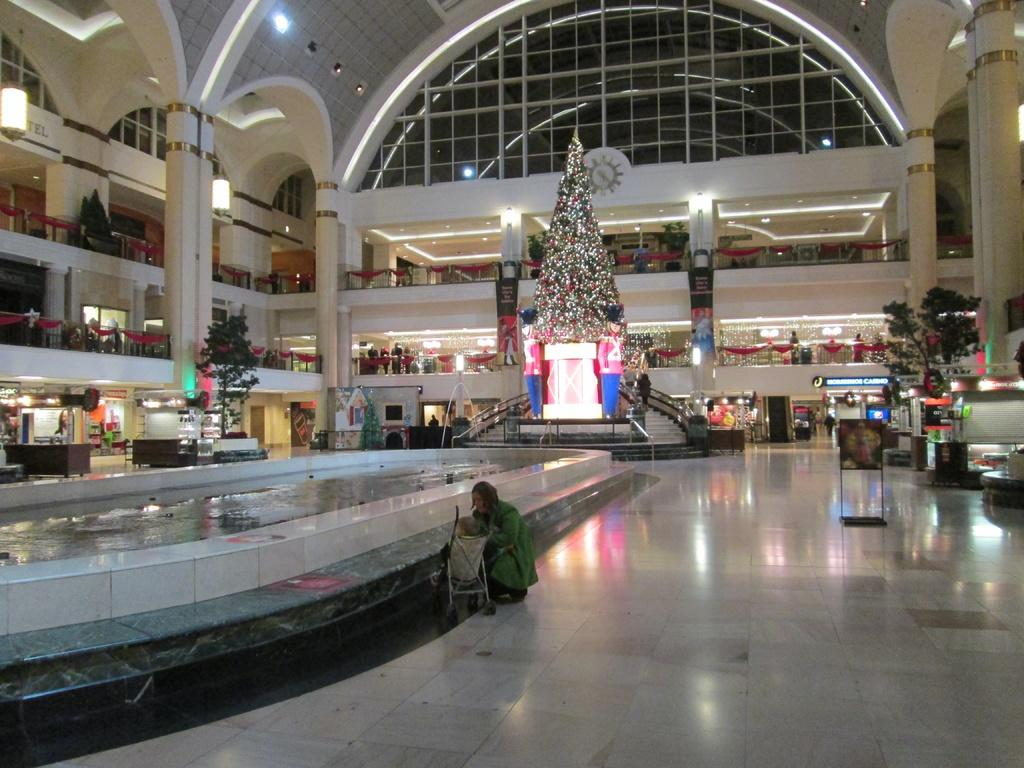What type of location is depicted in the image? The image shows the inside of a building. What holiday decoration can be seen in the building? There is a Christmas tree with lights in the building. What type of establishments are visible in the image? There are shops visible in the image. Are there any people present in the image? Yes, people are present in the image. What natural element can be seen in the image? There is water visible in the image. What type of legal proceedings are present in the image? State cases are present in the image. What type of canvas is being used to create a rhythm in the image? There is no canvas or rhythm present in the image. What is causing a sore throat in the image? There is no mention of a sore throat or any related cause in the image. 